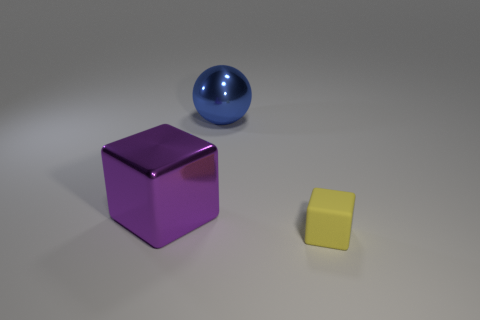There is another large thing that is the same shape as the rubber object; what is it made of?
Offer a terse response. Metal. Are there any other things that have the same material as the small object?
Offer a terse response. No. Does the cube on the left side of the yellow block have the same material as the thing in front of the big purple shiny thing?
Ensure brevity in your answer.  No. What is the color of the cube behind the thing in front of the block that is behind the yellow block?
Offer a terse response. Purple. What number of other things are the same shape as the big blue metallic thing?
Your response must be concise. 0. What number of things are green rubber cylinders or things behind the large purple thing?
Offer a terse response. 1. Are there any other blue metal spheres that have the same size as the blue ball?
Your answer should be very brief. No. Is the large purple cube made of the same material as the big sphere?
Make the answer very short. Yes. What number of things are gray matte balls or metal things?
Provide a short and direct response. 2. What size is the blue thing?
Ensure brevity in your answer.  Large. 